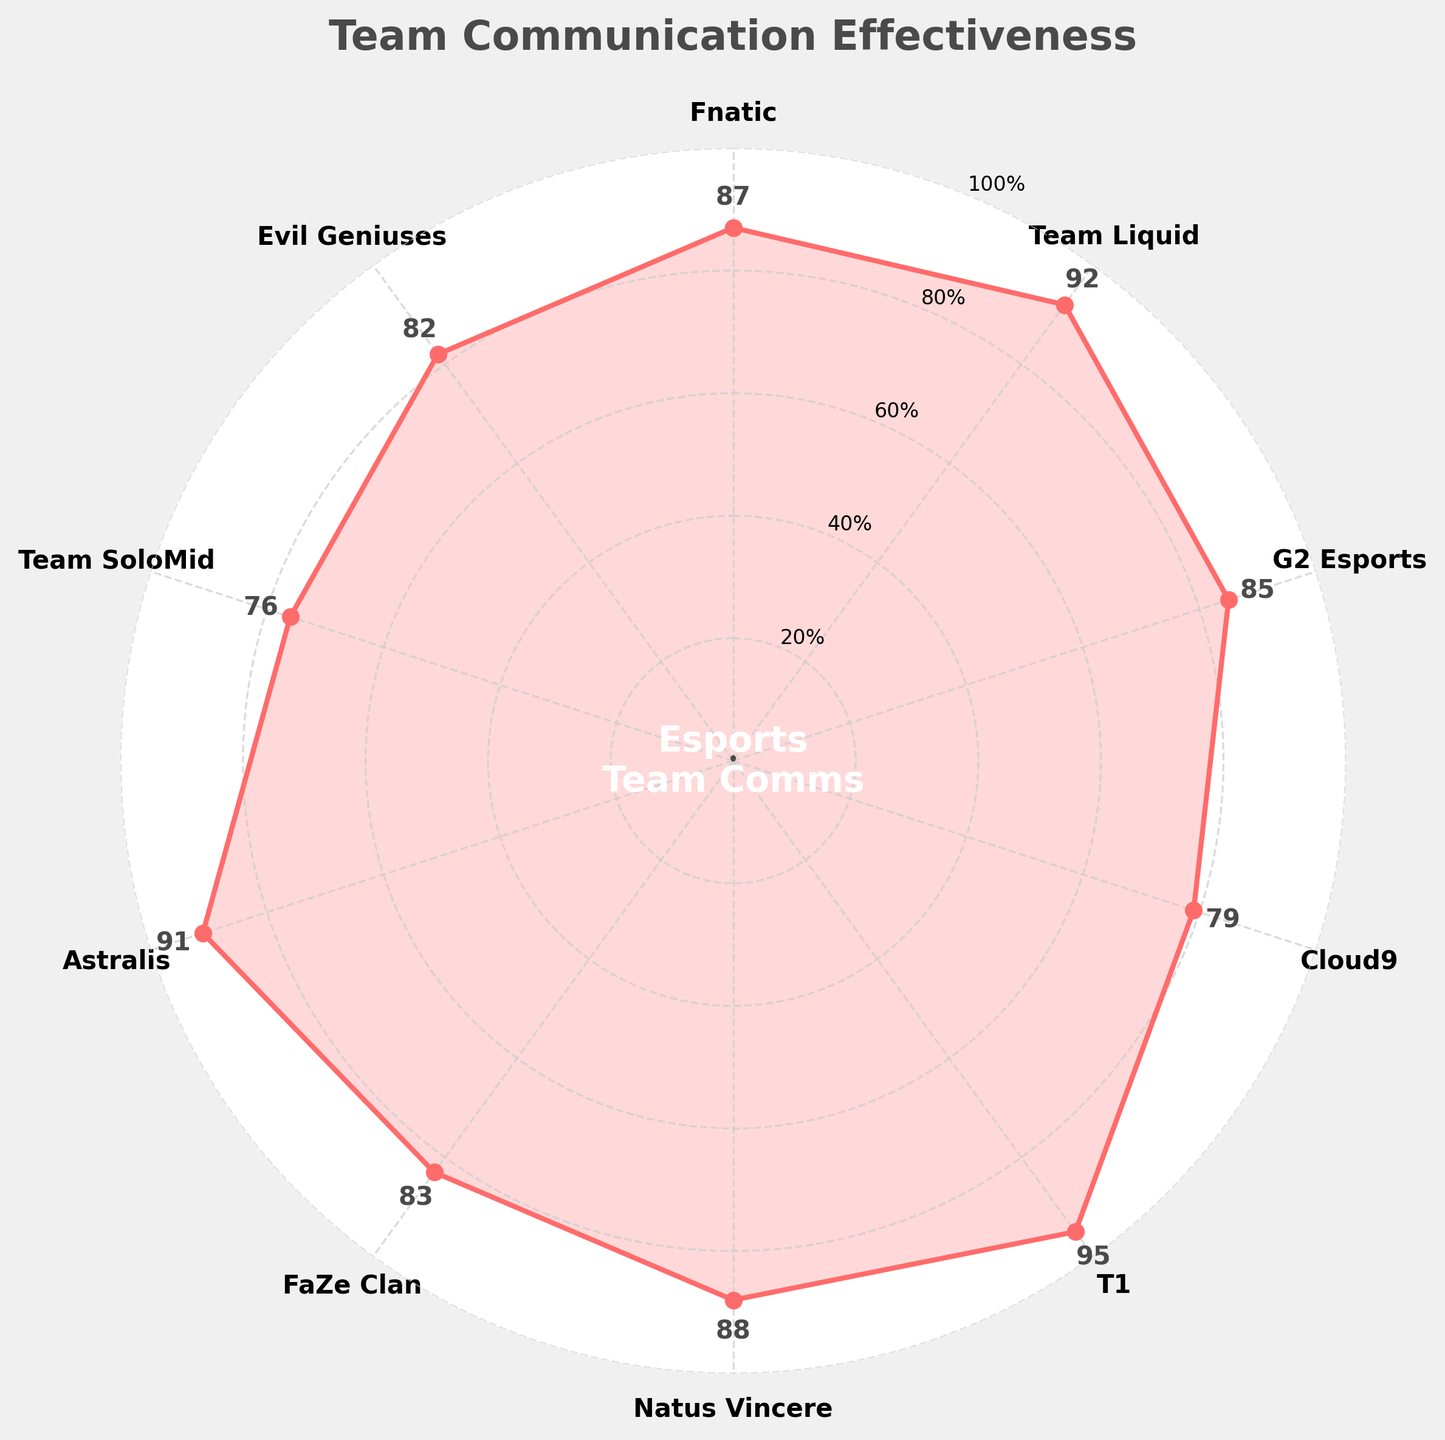Which team has the highest communication effectiveness score? To find the team with the highest communication effectiveness, we look at the values on the chart and identify the highest one. The highest value on the chart is 95.
Answer: T1 Which team has the lowest communication effectiveness score? To determine the team with the lowest communication effectiveness, we find the lowest value among the plotted scores. The lowest value is 76.
Answer: Team SoloMid What is the average communication effectiveness across all teams? First, sum all the communication effectiveness scores: 87 + 92 + 85 + 79 + 95 + 88 + 83 + 91 + 76 + 82 = 858. Then, divide by the number of teams, which is 10. Therefore, 858 / 10 = 85.8.
Answer: 85.8 Which teams have communication effectiveness scores greater than 90? Find all teams with scores above 90. These teams are Team Liquid (92), T1 (95), and Astralis (91).
Answer: Team Liquid, T1, Astralis What is the difference in communication effectiveness between G2 Esports and Cloud9? Look at the scores of G2 Esports (85) and Cloud9 (79). Subtract Cloud9's score from G2 Esports' score to get 85 - 79 = 6.
Answer: 6 Among the top 3 teams, what is the median communication effectiveness score? The top 3 teams are T1 (95), Team Liquid (92), and Astralis (91). The median of 95, 92, 91 is the middle value, which is 92.
Answer: 92 If we want to average the effectiveness scores of teams in the top half (top 5 teams), what would it be? The top 5 teams and their scores are: T1 (95), Team Liquid (92), Astralis (91), Natus Vincere (88), and Fnatic (87). Calculate the average: (95 + 92 + 91 + 88 + 87) / 5 = 90.6.
Answer: 90.6 How many teams have communication effectiveness scores below the average score? The average score is 85.8. Teams with scores below this are Cloud9 (79), Team SoloMid (76), Evil Geniuses (82), and FaZe Clan (83). Count these teams: 4 teams.
Answer: 4 What's the total communication effectiveness of the teams with a score below 85? Identify teams with scores below 85: Cloud9 (79), Team SoloMid (76), and Evil Geniuses (82). Sum these scores: 79 + 76 + 82 = 237.
Answer: 237 